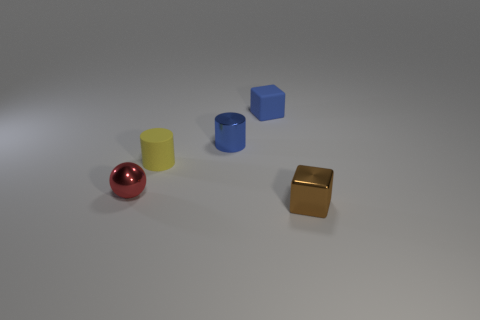Add 1 large gray cubes. How many objects exist? 6 Subtract all spheres. How many objects are left? 4 Subtract all tiny rubber cylinders. Subtract all tiny blue things. How many objects are left? 2 Add 2 small red shiny spheres. How many small red shiny spheres are left? 3 Add 3 big blue metallic blocks. How many big blue metallic blocks exist? 3 Subtract 0 cyan balls. How many objects are left? 5 